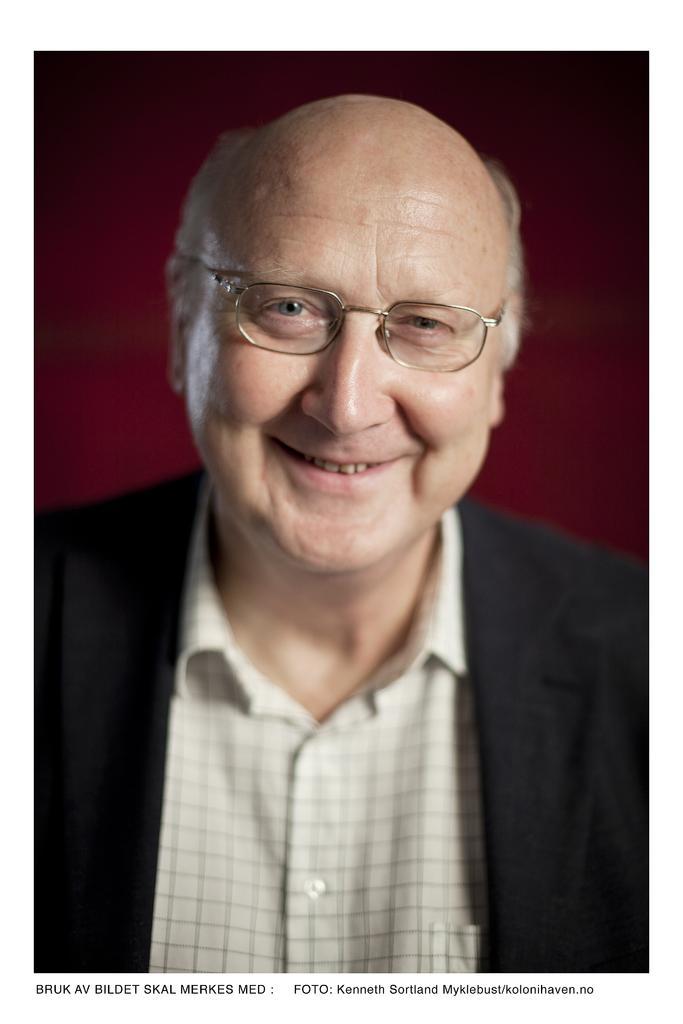Can you describe this image briefly? In this image, I can see the man smiling. He wore a shirt, suit and spectacle. The background looks maroon in color. I think these are the watermarks on the image. 